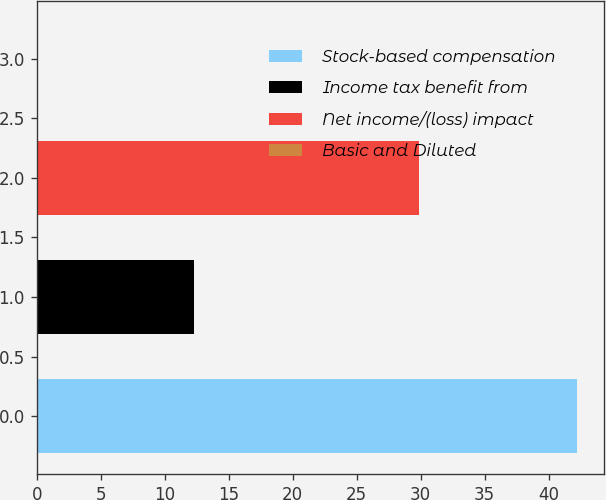<chart> <loc_0><loc_0><loc_500><loc_500><bar_chart><fcel>Stock-based compensation<fcel>Income tax benefit from<fcel>Net income/(loss) impact<fcel>Basic and Diluted<nl><fcel>42.2<fcel>12.3<fcel>29.9<fcel>0.06<nl></chart> 